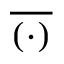<formula> <loc_0><loc_0><loc_500><loc_500>\overline { ( \cdot ) }</formula> 